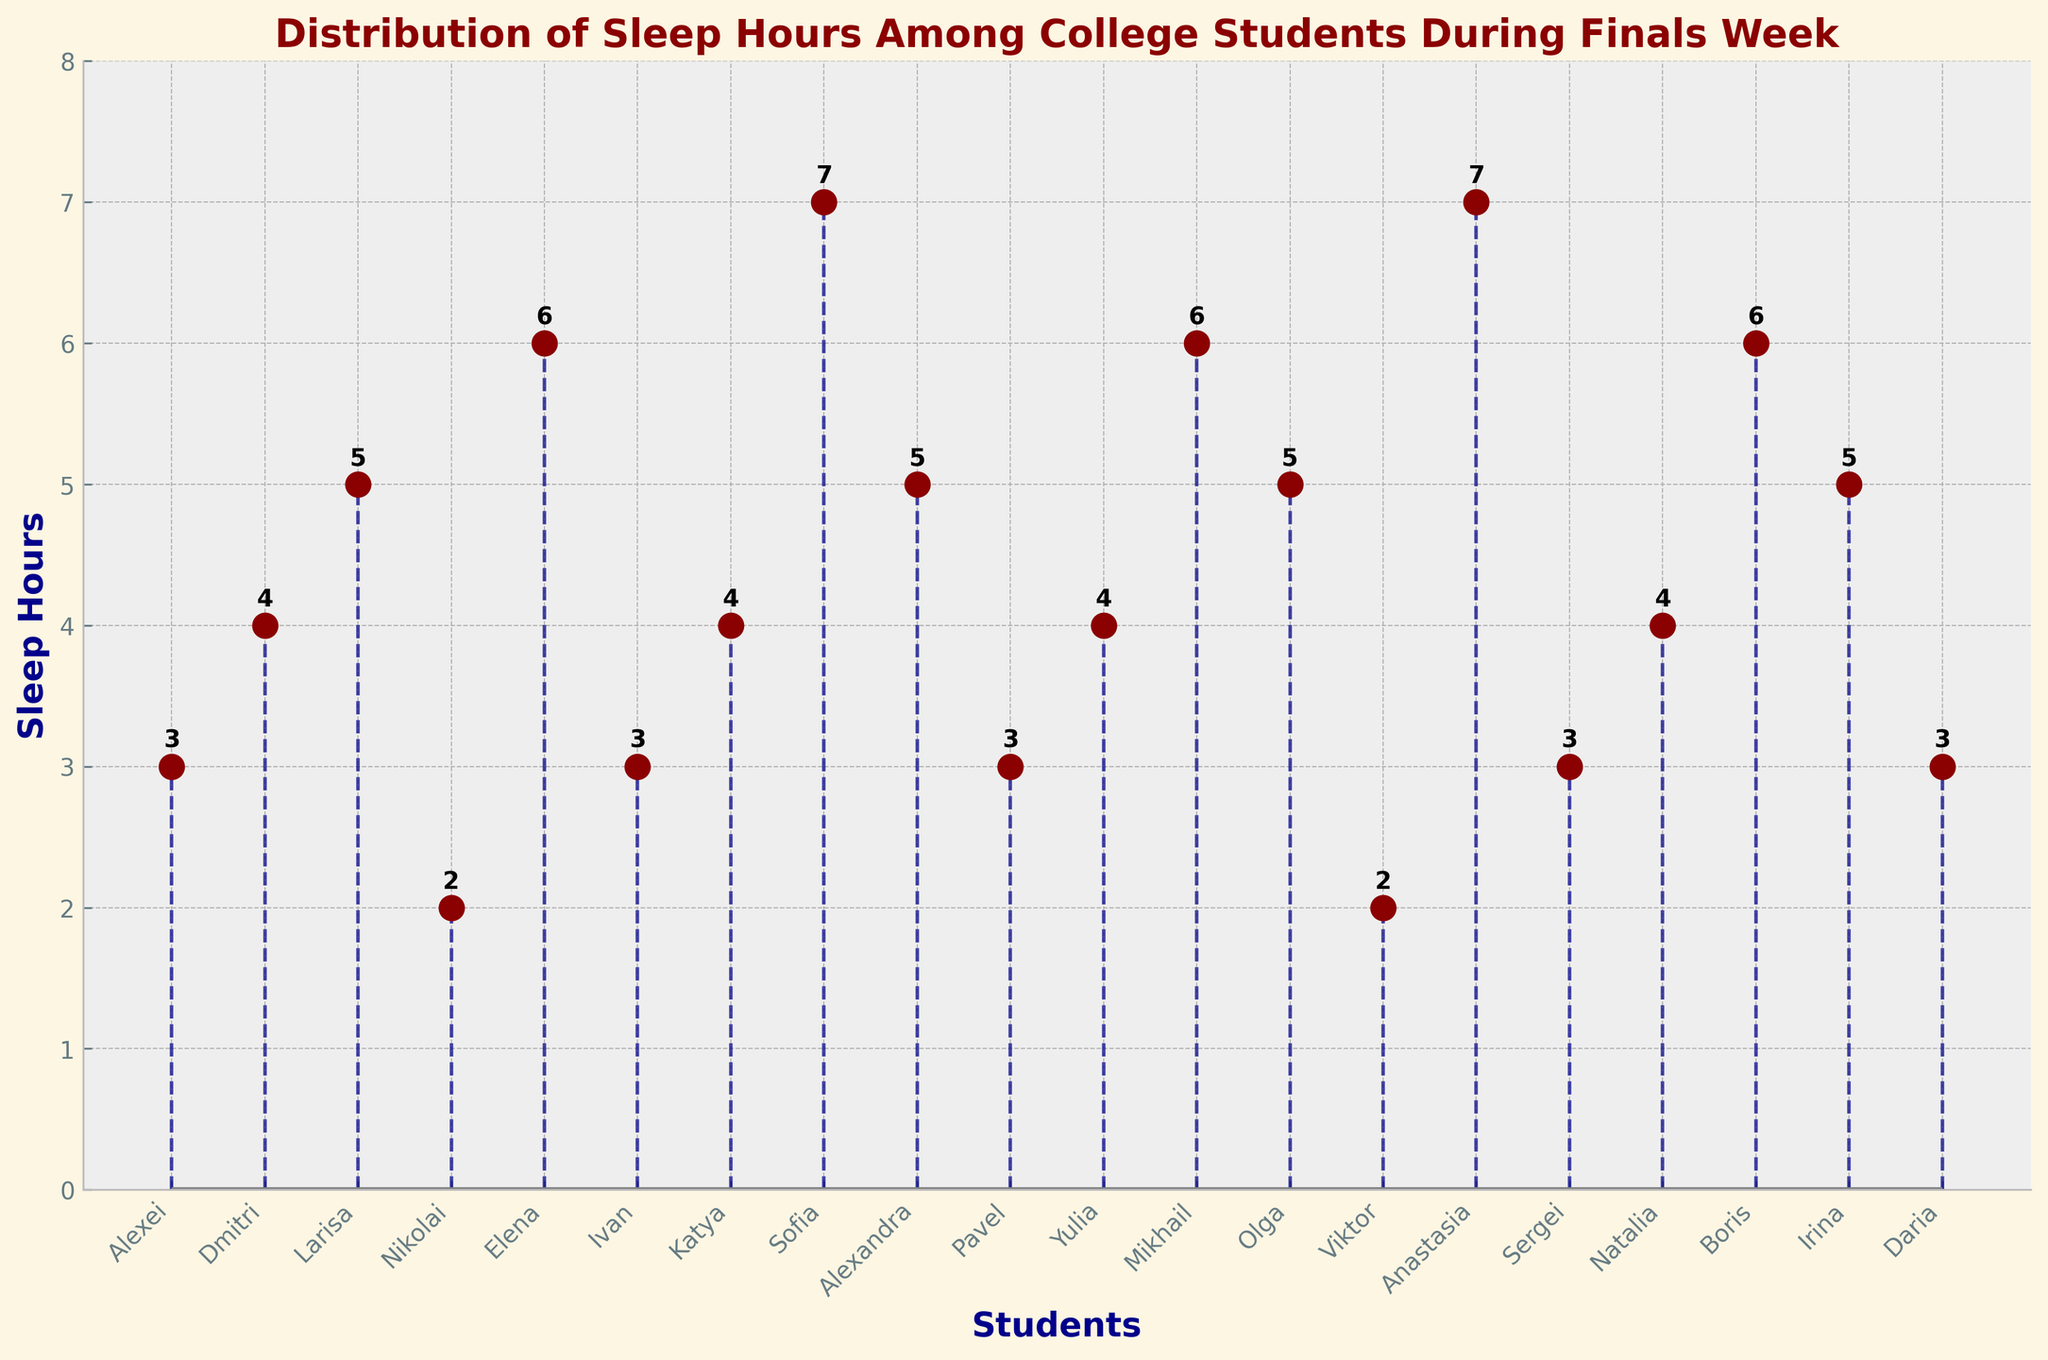What's the title of the figure? The figure title is displayed at the top of the plot in a bold font and highlighted in dark red. It provides the main topic of the graph.
Answer: Distribution of Sleep Hours Among College Students During Finals Week How many students sleep for only 2 hours? By counting the number of stem lines whose y-value reaches 2, we can see that there are two students.
Answer: 2 What is the highest number of sleep hours recorded in the figure? The topmost points of the stem lines represent the highest sleep hours, which is 7 hours.
Answer: 7 Which students sleep for 7 hours? Looking at the names at the x-axis corresponding to the 7 hours on the y-axis, we can see that Sofia and Anastasia sleep for 7 hours.
Answer: Sofia and Anastasia How many students sleep less than 5 hours? Counting the stem lines whose y-values are less than 5 hours reveals these students: Alexei, Dmitri, Nikolai, Ivan, Katya, Sergei, and Daria. There are 7 students.
Answer: 7 What is the average number of sleep hours among all the students? First, sum all sleep hours: 3+4+5+2+6+3+4+7+5+3+4+6+5+2+7+3+4+6+5+3 = 89. Divide by the number of students, which is 20. 89/20 = 4.45
Answer: 4.45 How does Katya's sleep duration compare to Larisa's? Katya's sleep duration is 4 hours, while Larisa's is 5 hours. We see that Katya sleeps 1 hour less than Larisa.
Answer: Katya sleeps 1 hour less than Larisa Which student has the same number of sleep hours as Pavel? Pavel's sleep duration is 3 hours. Other students with 3 hours of sleep include Alexei, Ivan, Sergei, and Daria.
Answer: Alexei, Ivan, Sergei, and Daria What is the most common sleep duration among the students? The most frequent y-values among all the stem lines indicate 3 and 4 hours, each occurring 5 times.
Answer: 3 and 4 hours (tie) How does the sleep of the most rested student compare to that of the most deprived? The most rested students (Sofia and Anastasia) sleep for 7 hours, while the most deprived students (Nikolai and Viktor) sleep for 2 hours. 7 hours minus 2 hours is 5 hours difference.
Answer: 5 hours more 